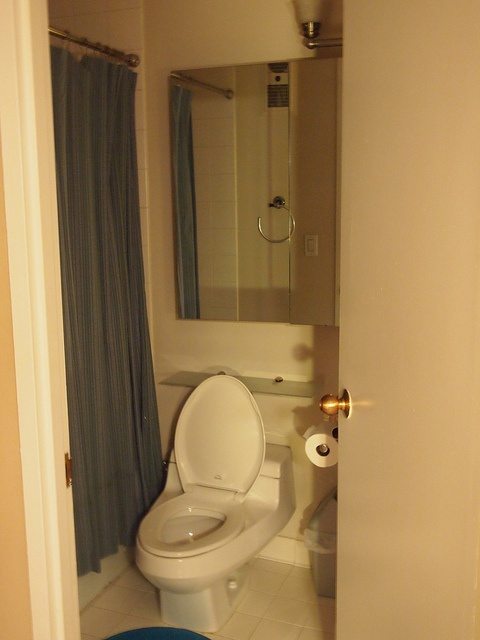Describe the objects in this image and their specific colors. I can see a toilet in tan and olive tones in this image. 